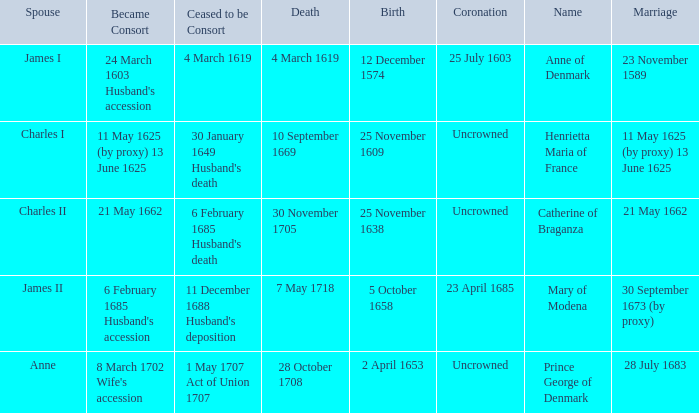Write the full table. {'header': ['Spouse', 'Became Consort', 'Ceased to be Consort', 'Death', 'Birth', 'Coronation', 'Name', 'Marriage'], 'rows': [['James I', "24 March 1603 Husband's accession", '4 March 1619', '4 March 1619', '12 December 1574', '25 July 1603', 'Anne of Denmark', '23 November 1589'], ['Charles I', '11 May 1625 (by proxy) 13 June 1625', "30 January 1649 Husband's death", '10 September 1669', '25 November 1609', 'Uncrowned', 'Henrietta Maria of France', '11 May 1625 (by proxy) 13 June 1625'], ['Charles II', '21 May 1662', "6 February 1685 Husband's death", '30 November 1705', '25 November 1638', 'Uncrowned', 'Catherine of Braganza', '21 May 1662'], ['James II', "6 February 1685 Husband's accession", "11 December 1688 Husband's deposition", '7 May 1718', '5 October 1658', '23 April 1685', 'Mary of Modena', '30 September 1673 (by proxy)'], ['Anne', "8 March 1702 Wife's accession", '1 May 1707 Act of Union 1707', '28 October 1708', '2 April 1653', 'Uncrowned', 'Prince George of Denmark', '28 July 1683']]} On what date did James II take a consort? 6 February 1685 Husband's accession. 